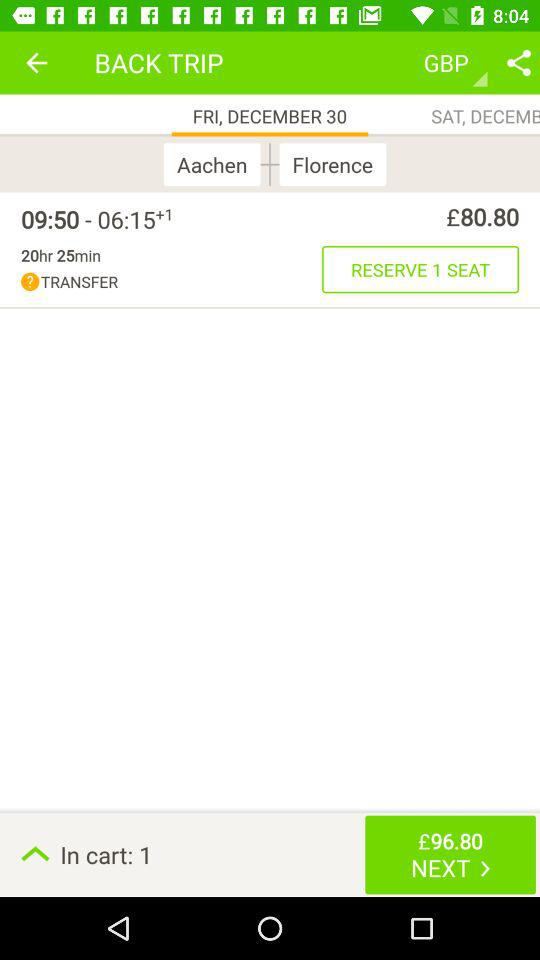How many items are in the cart? There is 1 item in the cart. 